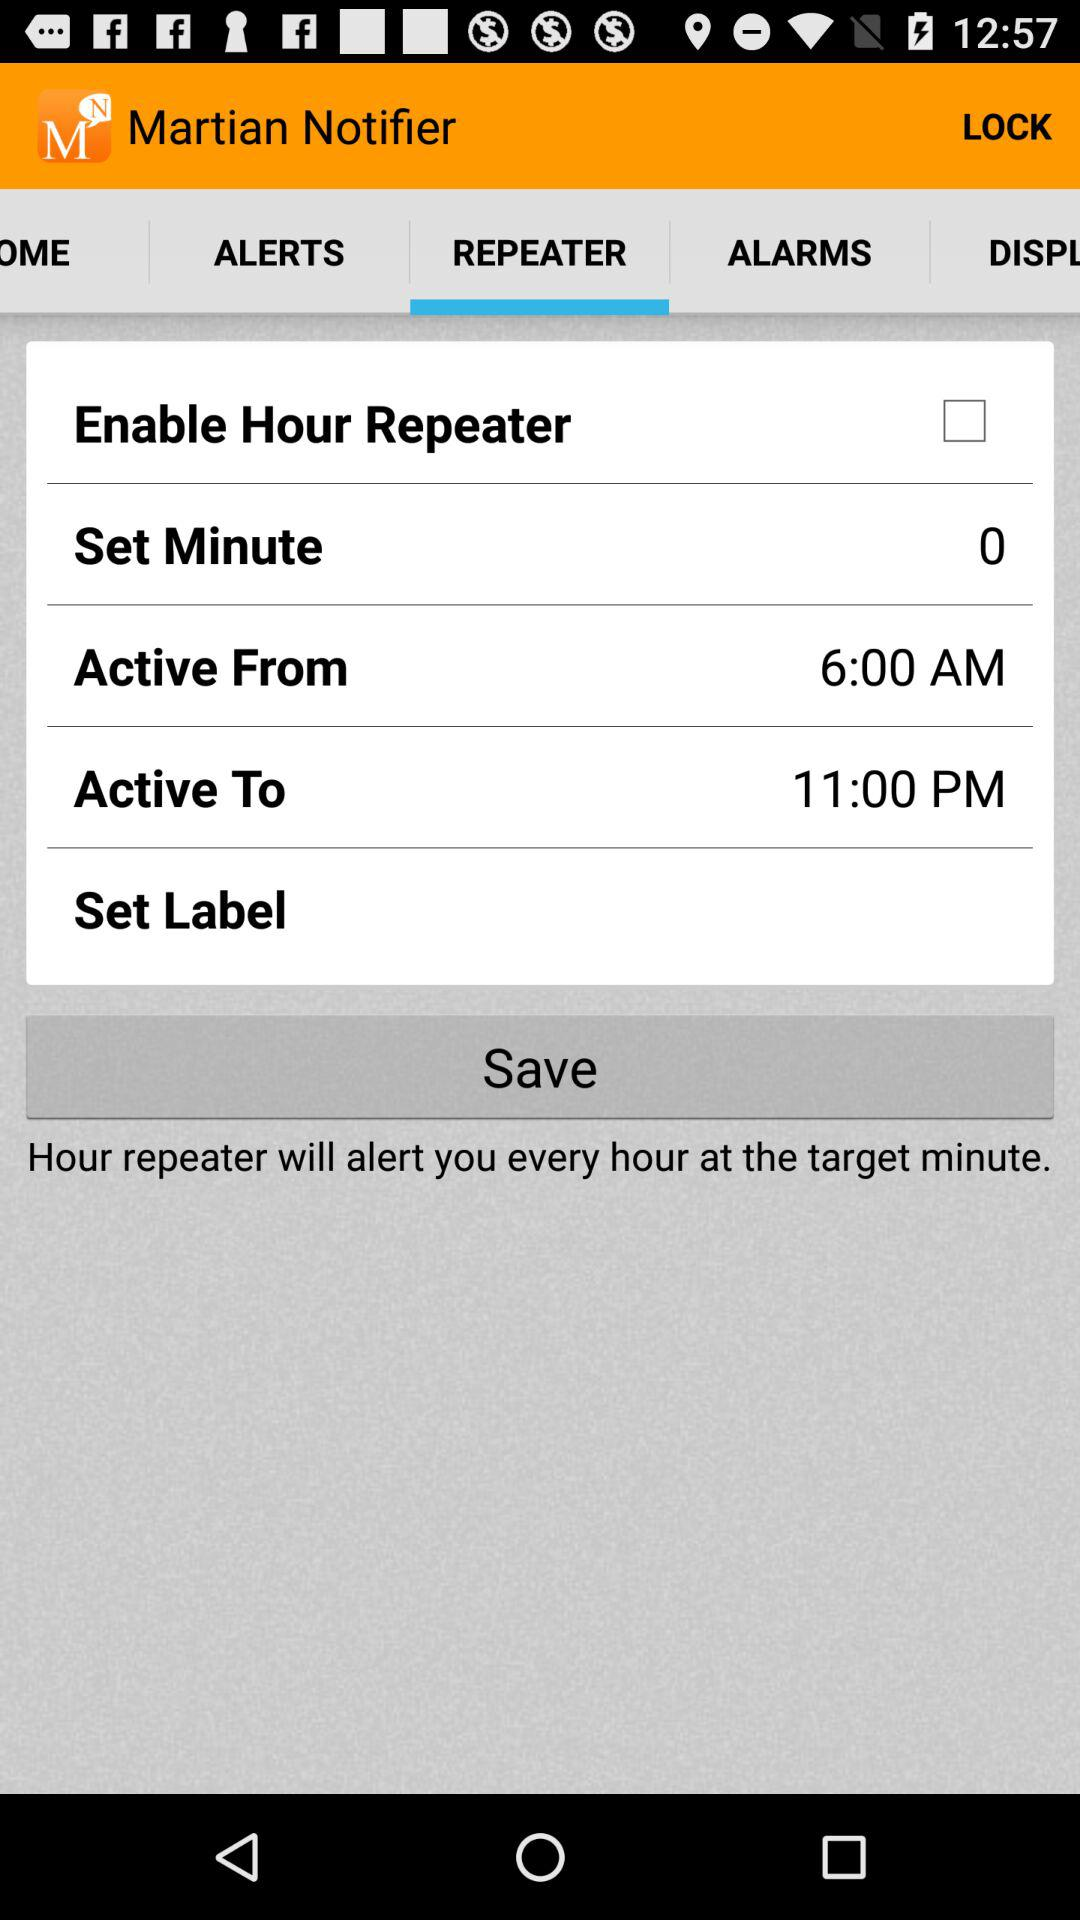What is the app's title? The app's title is "Martian Notifier". 